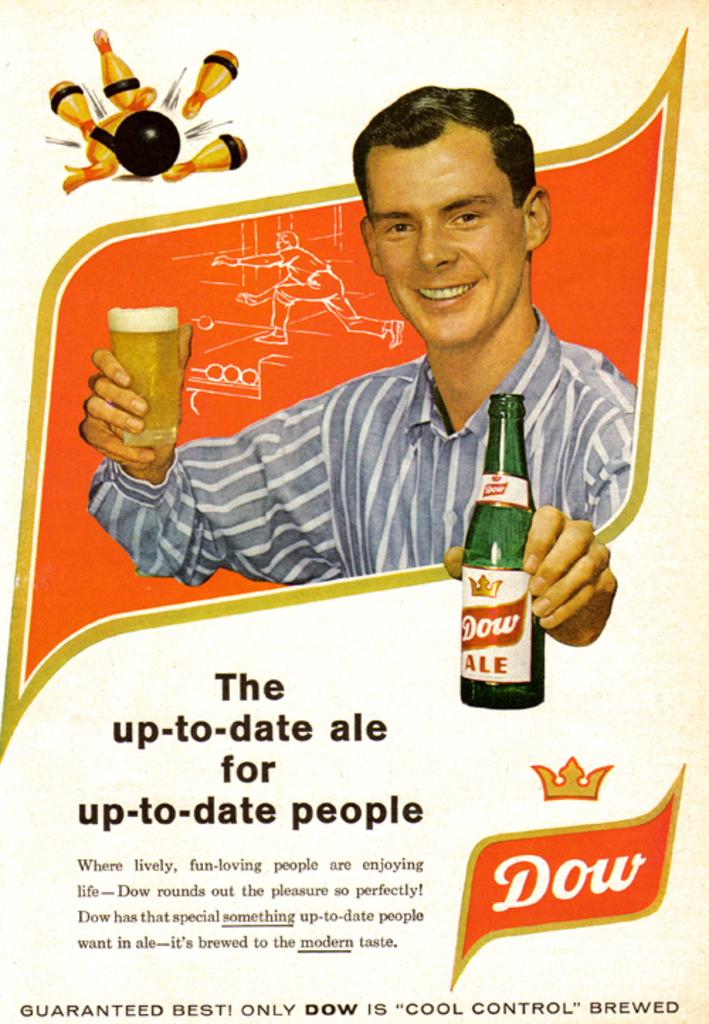<image>
Relay a brief, clear account of the picture shown. An advertisement for Dow Ale with a man on it. 